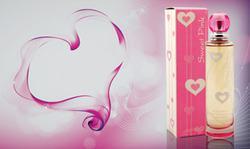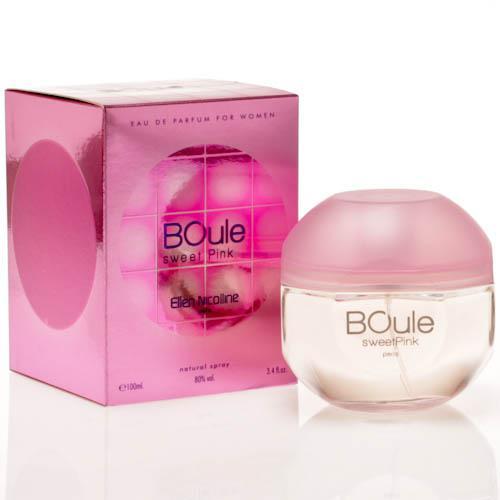The first image is the image on the left, the second image is the image on the right. For the images shown, is this caption "At least one bottle has a round ball on top of it." true? Answer yes or no. Yes. The first image is the image on the left, the second image is the image on the right. Assess this claim about the two images: "The left image features a cylindrical bottle with a hot pink rounded cap standing to the right of an upright hot pink box and slightly overlapping it.". Correct or not? Answer yes or no. Yes. 